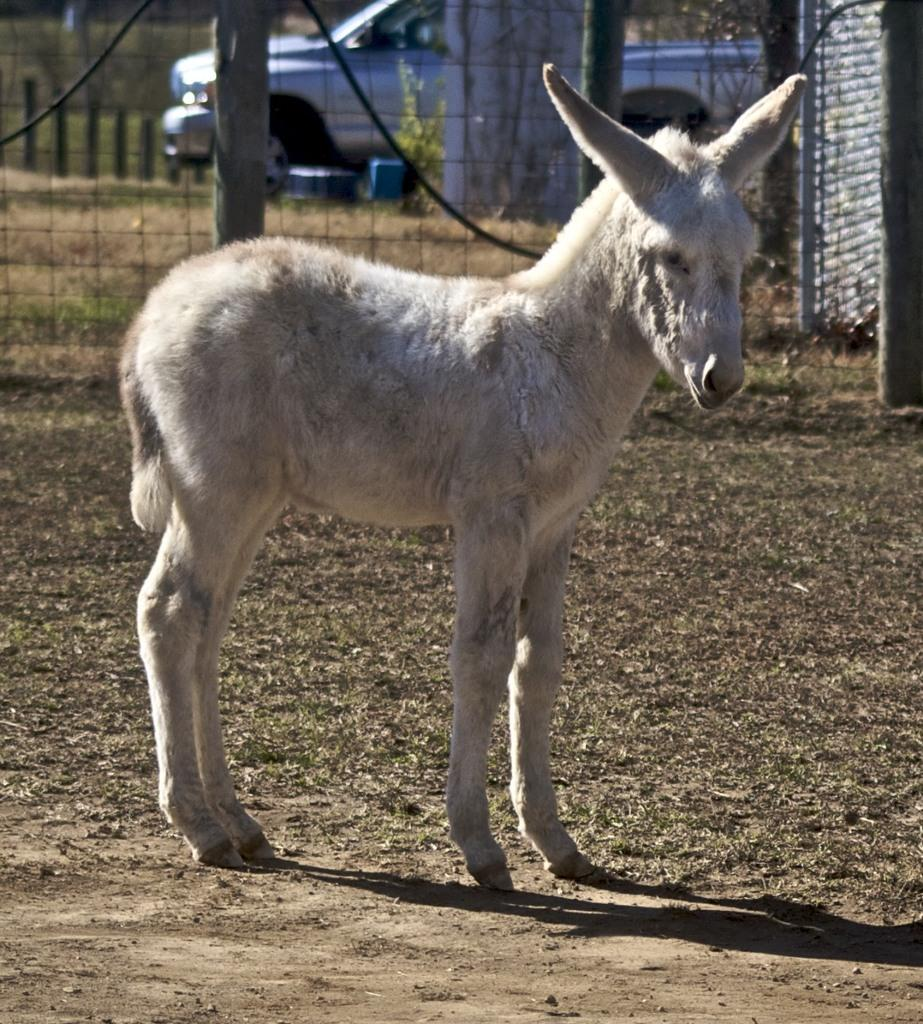What type of animal can be seen in the image? There is an animal in the image, and it is white in color. What is the animal doing in the image? The animal is standing on the ground. What can be seen in the background of the image? There is metal fencing and a vehicle on the ground in the background of the image. What type of hook is used to catch fish in the image? There is no hook present in the image; it features a white animal standing on the ground with metal fencing and a vehicle in the background. What type of game is being played in the image? There is no game being played in the image; it features a white animal standing on the ground with metal fencing and a vehicle in the background. 